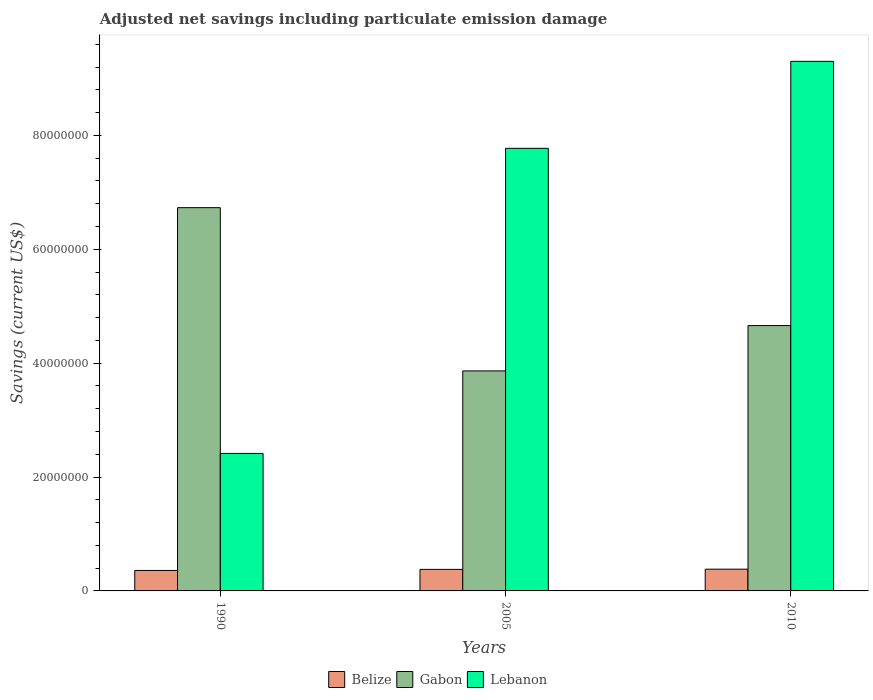How many groups of bars are there?
Make the answer very short. 3. Are the number of bars per tick equal to the number of legend labels?
Provide a succinct answer. Yes. Are the number of bars on each tick of the X-axis equal?
Offer a very short reply. Yes. How many bars are there on the 2nd tick from the left?
Make the answer very short. 3. How many bars are there on the 2nd tick from the right?
Make the answer very short. 3. What is the net savings in Lebanon in 2010?
Keep it short and to the point. 9.30e+07. Across all years, what is the maximum net savings in Gabon?
Keep it short and to the point. 6.73e+07. Across all years, what is the minimum net savings in Belize?
Offer a very short reply. 3.60e+06. In which year was the net savings in Belize minimum?
Provide a succinct answer. 1990. What is the total net savings in Lebanon in the graph?
Make the answer very short. 1.95e+08. What is the difference between the net savings in Lebanon in 1990 and that in 2010?
Make the answer very short. -6.89e+07. What is the difference between the net savings in Belize in 2010 and the net savings in Gabon in 1990?
Keep it short and to the point. -6.35e+07. What is the average net savings in Lebanon per year?
Your answer should be compact. 6.50e+07. In the year 2005, what is the difference between the net savings in Belize and net savings in Gabon?
Offer a very short reply. -3.49e+07. What is the ratio of the net savings in Gabon in 1990 to that in 2005?
Provide a succinct answer. 1.74. What is the difference between the highest and the second highest net savings in Gabon?
Your response must be concise. 2.07e+07. What is the difference between the highest and the lowest net savings in Gabon?
Provide a short and direct response. 2.87e+07. In how many years, is the net savings in Gabon greater than the average net savings in Gabon taken over all years?
Keep it short and to the point. 1. What does the 1st bar from the left in 2005 represents?
Give a very brief answer. Belize. What does the 3rd bar from the right in 1990 represents?
Make the answer very short. Belize. How many bars are there?
Offer a terse response. 9. How many years are there in the graph?
Your response must be concise. 3. What is the difference between two consecutive major ticks on the Y-axis?
Your response must be concise. 2.00e+07. Does the graph contain any zero values?
Ensure brevity in your answer.  No. Where does the legend appear in the graph?
Provide a short and direct response. Bottom center. How many legend labels are there?
Provide a short and direct response. 3. What is the title of the graph?
Make the answer very short. Adjusted net savings including particulate emission damage. Does "Vanuatu" appear as one of the legend labels in the graph?
Your answer should be compact. No. What is the label or title of the Y-axis?
Offer a terse response. Savings (current US$). What is the Savings (current US$) of Belize in 1990?
Provide a short and direct response. 3.60e+06. What is the Savings (current US$) of Gabon in 1990?
Provide a short and direct response. 6.73e+07. What is the Savings (current US$) of Lebanon in 1990?
Your response must be concise. 2.41e+07. What is the Savings (current US$) of Belize in 2005?
Make the answer very short. 3.78e+06. What is the Savings (current US$) of Gabon in 2005?
Give a very brief answer. 3.86e+07. What is the Savings (current US$) in Lebanon in 2005?
Your answer should be very brief. 7.77e+07. What is the Savings (current US$) in Belize in 2010?
Your answer should be very brief. 3.82e+06. What is the Savings (current US$) of Gabon in 2010?
Your answer should be compact. 4.66e+07. What is the Savings (current US$) of Lebanon in 2010?
Give a very brief answer. 9.30e+07. Across all years, what is the maximum Savings (current US$) in Belize?
Your response must be concise. 3.82e+06. Across all years, what is the maximum Savings (current US$) of Gabon?
Offer a very short reply. 6.73e+07. Across all years, what is the maximum Savings (current US$) of Lebanon?
Your answer should be compact. 9.30e+07. Across all years, what is the minimum Savings (current US$) of Belize?
Provide a short and direct response. 3.60e+06. Across all years, what is the minimum Savings (current US$) of Gabon?
Provide a short and direct response. 3.86e+07. Across all years, what is the minimum Savings (current US$) in Lebanon?
Provide a short and direct response. 2.41e+07. What is the total Savings (current US$) of Belize in the graph?
Offer a terse response. 1.12e+07. What is the total Savings (current US$) of Gabon in the graph?
Keep it short and to the point. 1.53e+08. What is the total Savings (current US$) of Lebanon in the graph?
Ensure brevity in your answer.  1.95e+08. What is the difference between the Savings (current US$) in Belize in 1990 and that in 2005?
Ensure brevity in your answer.  -1.86e+05. What is the difference between the Savings (current US$) of Gabon in 1990 and that in 2005?
Provide a succinct answer. 2.87e+07. What is the difference between the Savings (current US$) of Lebanon in 1990 and that in 2005?
Your answer should be compact. -5.36e+07. What is the difference between the Savings (current US$) in Belize in 1990 and that in 2010?
Your answer should be very brief. -2.20e+05. What is the difference between the Savings (current US$) of Gabon in 1990 and that in 2010?
Keep it short and to the point. 2.07e+07. What is the difference between the Savings (current US$) in Lebanon in 1990 and that in 2010?
Provide a succinct answer. -6.89e+07. What is the difference between the Savings (current US$) of Belize in 2005 and that in 2010?
Your answer should be compact. -3.43e+04. What is the difference between the Savings (current US$) in Gabon in 2005 and that in 2010?
Make the answer very short. -7.96e+06. What is the difference between the Savings (current US$) in Lebanon in 2005 and that in 2010?
Provide a short and direct response. -1.53e+07. What is the difference between the Savings (current US$) of Belize in 1990 and the Savings (current US$) of Gabon in 2005?
Provide a succinct answer. -3.50e+07. What is the difference between the Savings (current US$) in Belize in 1990 and the Savings (current US$) in Lebanon in 2005?
Ensure brevity in your answer.  -7.41e+07. What is the difference between the Savings (current US$) of Gabon in 1990 and the Savings (current US$) of Lebanon in 2005?
Keep it short and to the point. -1.04e+07. What is the difference between the Savings (current US$) in Belize in 1990 and the Savings (current US$) in Gabon in 2010?
Ensure brevity in your answer.  -4.30e+07. What is the difference between the Savings (current US$) of Belize in 1990 and the Savings (current US$) of Lebanon in 2010?
Give a very brief answer. -8.94e+07. What is the difference between the Savings (current US$) in Gabon in 1990 and the Savings (current US$) in Lebanon in 2010?
Provide a short and direct response. -2.57e+07. What is the difference between the Savings (current US$) in Belize in 2005 and the Savings (current US$) in Gabon in 2010?
Make the answer very short. -4.28e+07. What is the difference between the Savings (current US$) of Belize in 2005 and the Savings (current US$) of Lebanon in 2010?
Your response must be concise. -8.92e+07. What is the difference between the Savings (current US$) of Gabon in 2005 and the Savings (current US$) of Lebanon in 2010?
Keep it short and to the point. -5.44e+07. What is the average Savings (current US$) in Belize per year?
Provide a succinct answer. 3.73e+06. What is the average Savings (current US$) of Gabon per year?
Provide a succinct answer. 5.08e+07. What is the average Savings (current US$) of Lebanon per year?
Offer a terse response. 6.50e+07. In the year 1990, what is the difference between the Savings (current US$) of Belize and Savings (current US$) of Gabon?
Keep it short and to the point. -6.37e+07. In the year 1990, what is the difference between the Savings (current US$) of Belize and Savings (current US$) of Lebanon?
Give a very brief answer. -2.05e+07. In the year 1990, what is the difference between the Savings (current US$) in Gabon and Savings (current US$) in Lebanon?
Keep it short and to the point. 4.32e+07. In the year 2005, what is the difference between the Savings (current US$) in Belize and Savings (current US$) in Gabon?
Keep it short and to the point. -3.49e+07. In the year 2005, what is the difference between the Savings (current US$) of Belize and Savings (current US$) of Lebanon?
Your answer should be compact. -7.39e+07. In the year 2005, what is the difference between the Savings (current US$) in Gabon and Savings (current US$) in Lebanon?
Ensure brevity in your answer.  -3.91e+07. In the year 2010, what is the difference between the Savings (current US$) in Belize and Savings (current US$) in Gabon?
Provide a short and direct response. -4.28e+07. In the year 2010, what is the difference between the Savings (current US$) of Belize and Savings (current US$) of Lebanon?
Your answer should be compact. -8.92e+07. In the year 2010, what is the difference between the Savings (current US$) in Gabon and Savings (current US$) in Lebanon?
Make the answer very short. -4.64e+07. What is the ratio of the Savings (current US$) in Belize in 1990 to that in 2005?
Your answer should be compact. 0.95. What is the ratio of the Savings (current US$) of Gabon in 1990 to that in 2005?
Your response must be concise. 1.74. What is the ratio of the Savings (current US$) of Lebanon in 1990 to that in 2005?
Your response must be concise. 0.31. What is the ratio of the Savings (current US$) of Belize in 1990 to that in 2010?
Keep it short and to the point. 0.94. What is the ratio of the Savings (current US$) of Gabon in 1990 to that in 2010?
Your answer should be very brief. 1.44. What is the ratio of the Savings (current US$) in Lebanon in 1990 to that in 2010?
Your answer should be very brief. 0.26. What is the ratio of the Savings (current US$) of Gabon in 2005 to that in 2010?
Ensure brevity in your answer.  0.83. What is the ratio of the Savings (current US$) of Lebanon in 2005 to that in 2010?
Your response must be concise. 0.84. What is the difference between the highest and the second highest Savings (current US$) in Belize?
Your response must be concise. 3.43e+04. What is the difference between the highest and the second highest Savings (current US$) in Gabon?
Offer a terse response. 2.07e+07. What is the difference between the highest and the second highest Savings (current US$) of Lebanon?
Offer a very short reply. 1.53e+07. What is the difference between the highest and the lowest Savings (current US$) of Belize?
Ensure brevity in your answer.  2.20e+05. What is the difference between the highest and the lowest Savings (current US$) in Gabon?
Your response must be concise. 2.87e+07. What is the difference between the highest and the lowest Savings (current US$) of Lebanon?
Your answer should be compact. 6.89e+07. 